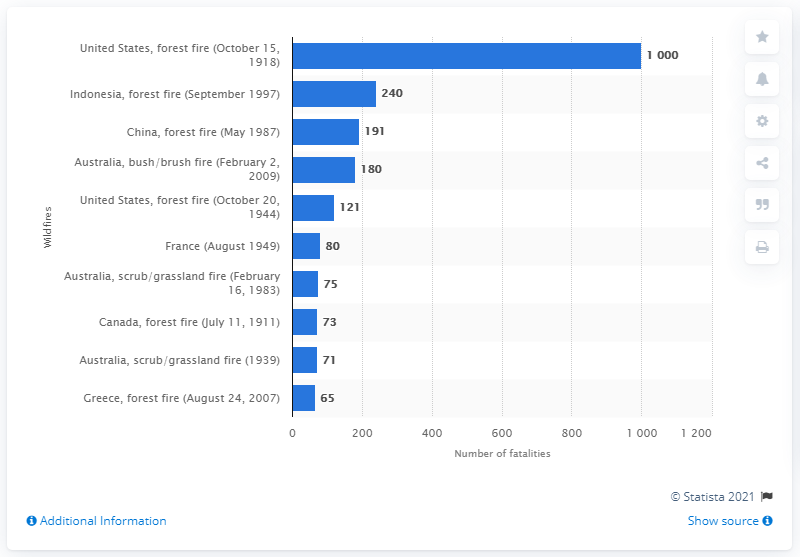Mention a couple of crucial points in this snapshot. In February 2009, a wildfire in Australia resulted in the loss of 180 lives. 